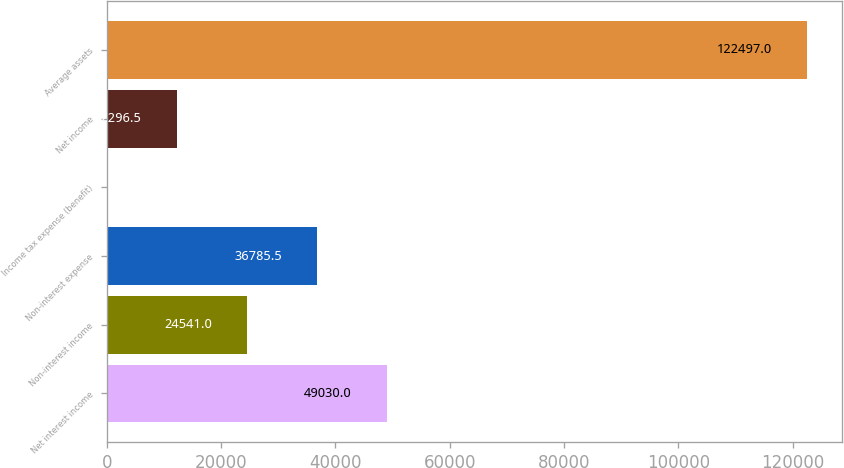Convert chart to OTSL. <chart><loc_0><loc_0><loc_500><loc_500><bar_chart><fcel>Net interest income<fcel>Non-interest income<fcel>Non-interest expense<fcel>Income tax expense (benefit)<fcel>Net income<fcel>Average assets<nl><fcel>49030<fcel>24541<fcel>36785.5<fcel>52<fcel>12296.5<fcel>122497<nl></chart> 